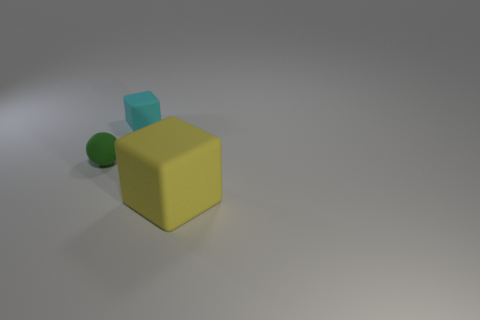Add 1 matte things. How many objects exist? 4 Subtract all blocks. How many objects are left? 1 Add 3 rubber cubes. How many rubber cubes exist? 5 Subtract 1 cyan blocks. How many objects are left? 2 Subtract all small matte balls. Subtract all big yellow rubber objects. How many objects are left? 1 Add 1 green rubber objects. How many green rubber objects are left? 2 